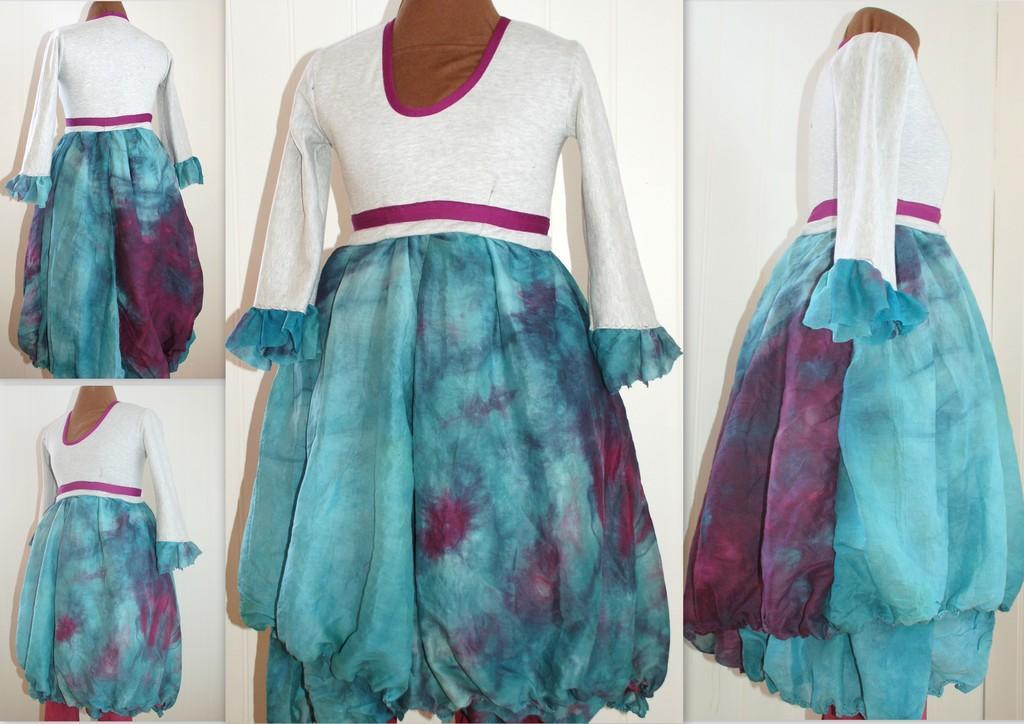Please provide a concise description of this image. This is a collage image. There is a dress in the images. 